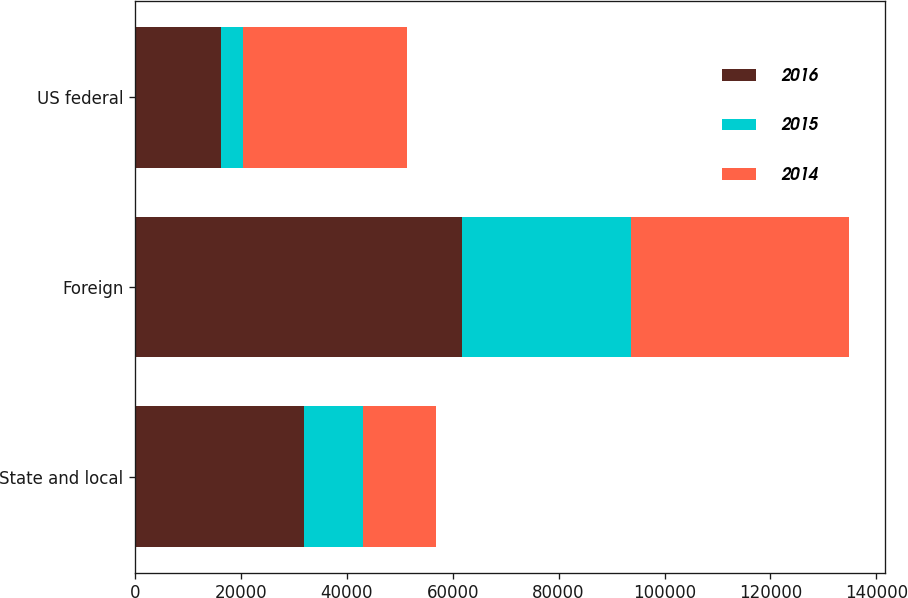<chart> <loc_0><loc_0><loc_500><loc_500><stacked_bar_chart><ecel><fcel>State and local<fcel>Foreign<fcel>US federal<nl><fcel>2016<fcel>31939<fcel>61712<fcel>16167<nl><fcel>2015<fcel>11175<fcel>31981<fcel>4165<nl><fcel>2014<fcel>13686<fcel>41151<fcel>31052<nl></chart> 